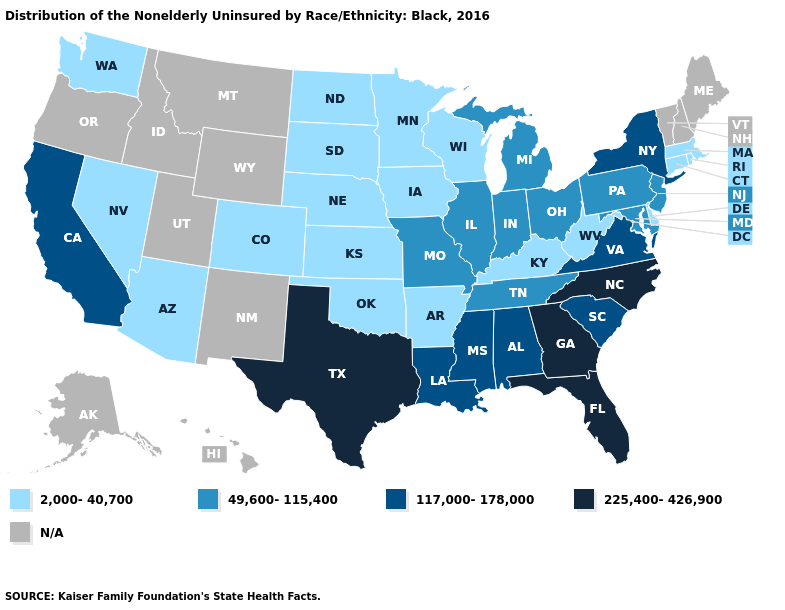What is the value of Oregon?
Quick response, please. N/A. Which states have the lowest value in the USA?
Give a very brief answer. Arizona, Arkansas, Colorado, Connecticut, Delaware, Iowa, Kansas, Kentucky, Massachusetts, Minnesota, Nebraska, Nevada, North Dakota, Oklahoma, Rhode Island, South Dakota, Washington, West Virginia, Wisconsin. What is the value of Virginia?
Quick response, please. 117,000-178,000. What is the value of Washington?
Give a very brief answer. 2,000-40,700. What is the highest value in the USA?
Short answer required. 225,400-426,900. Name the states that have a value in the range 49,600-115,400?
Short answer required. Illinois, Indiana, Maryland, Michigan, Missouri, New Jersey, Ohio, Pennsylvania, Tennessee. Does Arizona have the lowest value in the USA?
Short answer required. Yes. Name the states that have a value in the range 225,400-426,900?
Quick response, please. Florida, Georgia, North Carolina, Texas. Among the states that border Nebraska , does Iowa have the lowest value?
Concise answer only. Yes. Name the states that have a value in the range 225,400-426,900?
Keep it brief. Florida, Georgia, North Carolina, Texas. Does Rhode Island have the highest value in the USA?
Concise answer only. No. What is the lowest value in states that border Oregon?
Quick response, please. 2,000-40,700. Does California have the lowest value in the West?
Short answer required. No. What is the lowest value in the USA?
Quick response, please. 2,000-40,700. 